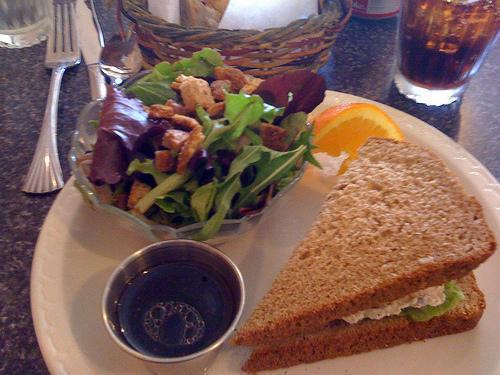How many spoons are pictured?
Give a very brief answer. 1. 